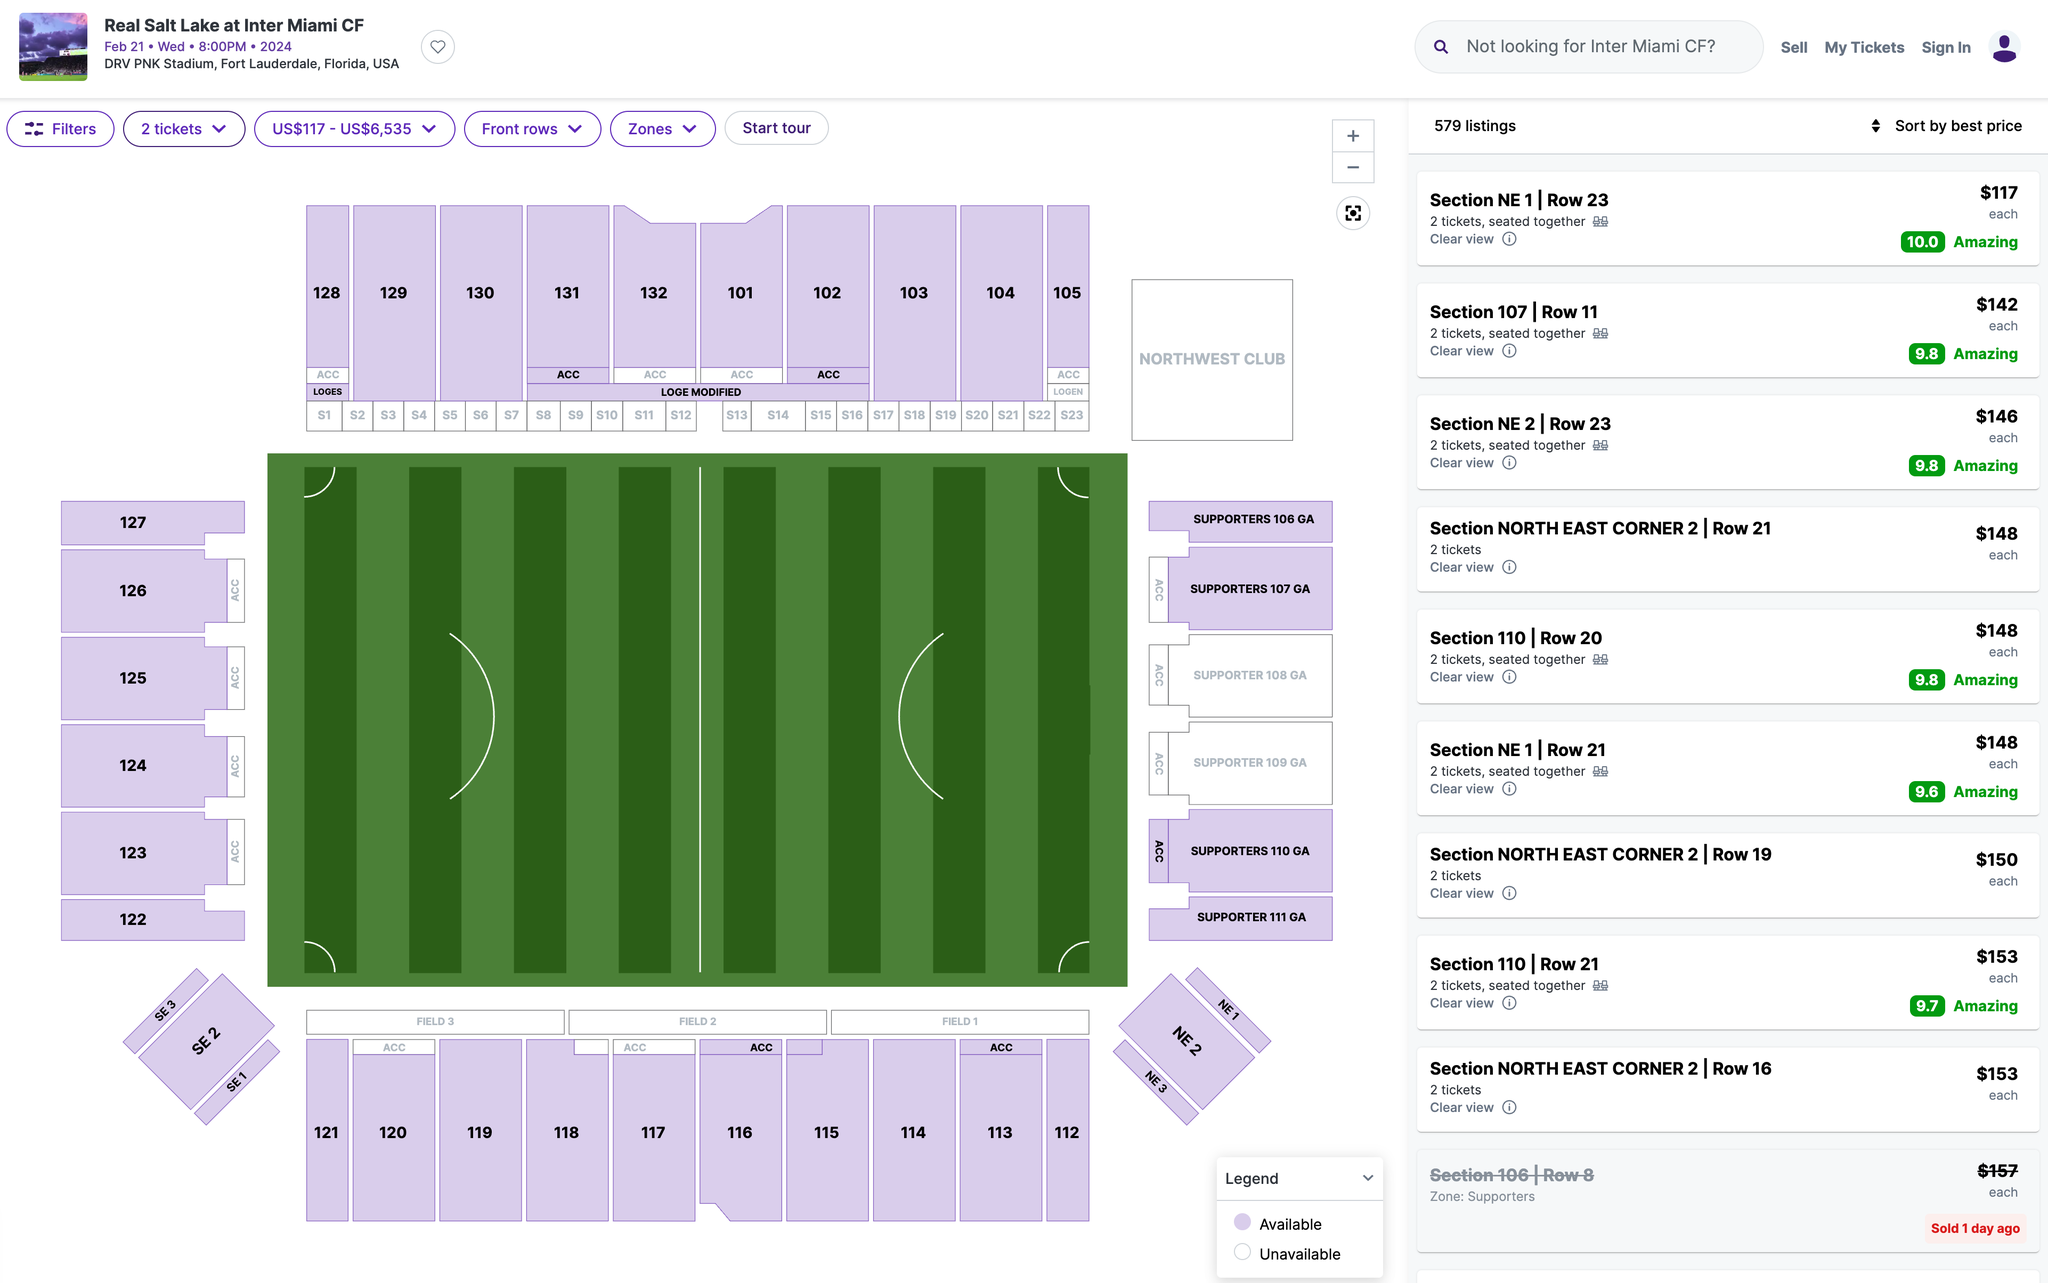Which section's ticket would you recommend I purchase? I recommend purchasing tickets in Section 107. This section is located on the west side of the stadium, and it offers a great view of the field. Additionally, this section is relatively close to the action, so you'll be able to see the players up close. 